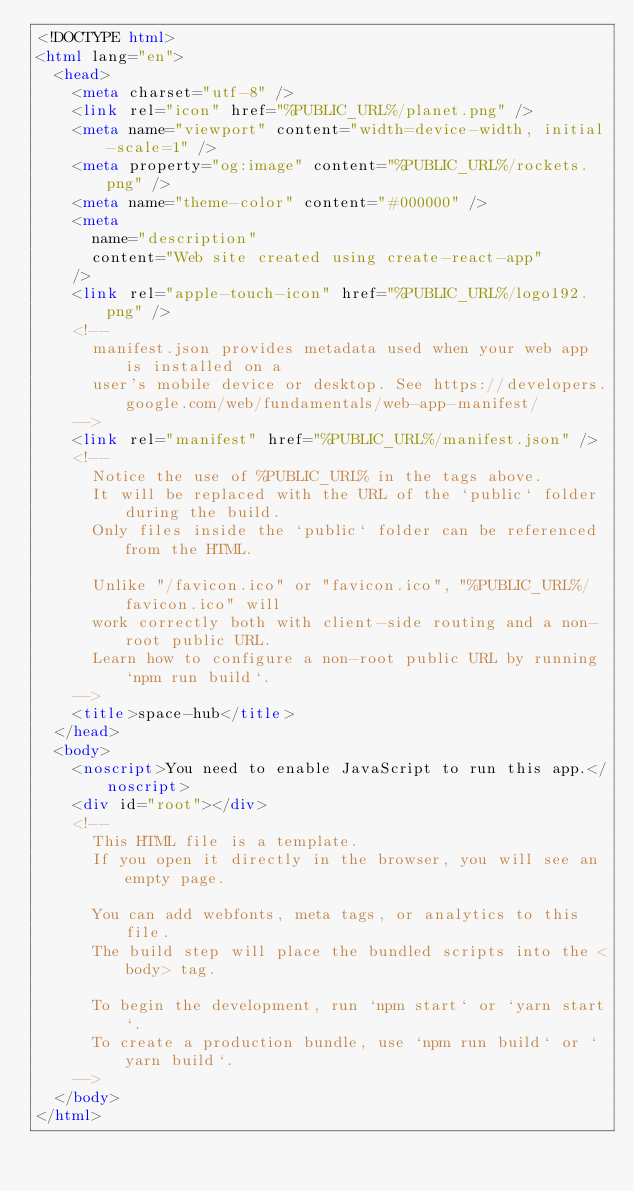Convert code to text. <code><loc_0><loc_0><loc_500><loc_500><_HTML_><!DOCTYPE html>
<html lang="en">
  <head>
    <meta charset="utf-8" />
    <link rel="icon" href="%PUBLIC_URL%/planet.png" />
    <meta name="viewport" content="width=device-width, initial-scale=1" />
    <meta property="og:image" content="%PUBLIC_URL%/rockets.png" />
    <meta name="theme-color" content="#000000" />
    <meta
      name="description"
      content="Web site created using create-react-app"
    />
    <link rel="apple-touch-icon" href="%PUBLIC_URL%/logo192.png" />
    <!--
      manifest.json provides metadata used when your web app is installed on a
      user's mobile device or desktop. See https://developers.google.com/web/fundamentals/web-app-manifest/
    -->
    <link rel="manifest" href="%PUBLIC_URL%/manifest.json" />
    <!--
      Notice the use of %PUBLIC_URL% in the tags above.
      It will be replaced with the URL of the `public` folder during the build.
      Only files inside the `public` folder can be referenced from the HTML.

      Unlike "/favicon.ico" or "favicon.ico", "%PUBLIC_URL%/favicon.ico" will
      work correctly both with client-side routing and a non-root public URL.
      Learn how to configure a non-root public URL by running `npm run build`.
    -->
    <title>space-hub</title>
  </head>
  <body>
    <noscript>You need to enable JavaScript to run this app.</noscript>
    <div id="root"></div>
    <!--
      This HTML file is a template.
      If you open it directly in the browser, you will see an empty page.

      You can add webfonts, meta tags, or analytics to this file.
      The build step will place the bundled scripts into the <body> tag.

      To begin the development, run `npm start` or `yarn start`.
      To create a production bundle, use `npm run build` or `yarn build`.
    -->
  </body>
</html>
</code> 